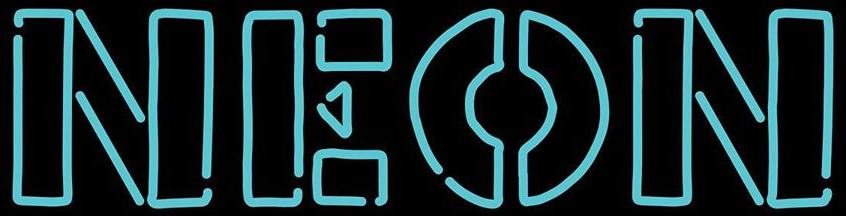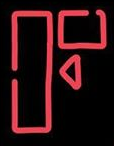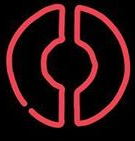Transcribe the words shown in these images in order, separated by a semicolon. NEON; F; O 